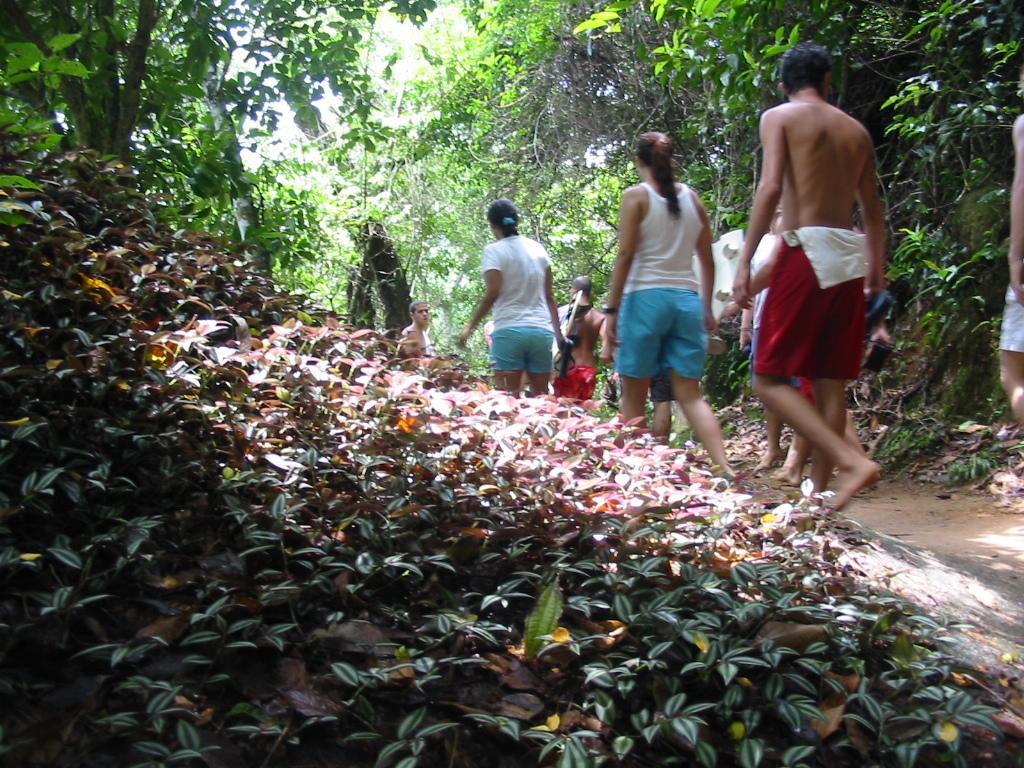How would you summarize this image in a sentence or two? In this image, we can see some plants. There are some persons in the middle of the image wearing clothes and walking on the path. There are trees at the top of the image. 